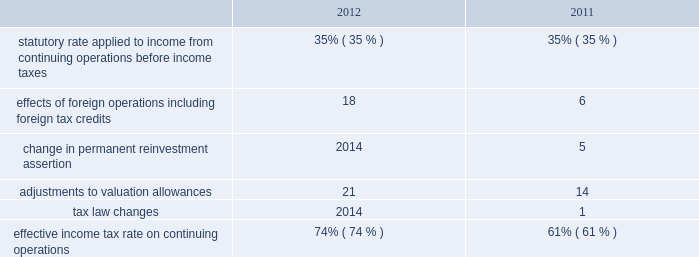Provision for income taxes increased $ 1791 million in 2012 from 2011 primarily due to the increase in pretax income from continuing operations , including the impact of the resumption of sales in libya in the first quarter of 2012 .
The following is an analysis of the effective income tax rates for 2012 and 2011: .
The effective income tax rate is influenced by a variety of factors including the geographic sources of income and the relative magnitude of these sources of income .
The provision for income taxes is allocated on a discrete , stand-alone basis to pretax segment income and to individual items not allocated to segments .
The difference between the total provision and the sum of the amounts allocated to segments appears in the "corporate and other unallocated items" shown in the reconciliation of segment income to net income below .
Effects of foreign operations 2013 the effects of foreign operations on our effective tax rate increased in 2012 as compared to 2011 , primarily due to the resumption of sales in libya in the first quarter of 2012 , where the statutory rate is in excess of 90 percent .
Change in permanent reinvestment assertion 2013 in the second quarter of 2011 , we recorded $ 716 million of deferred u.s .
Tax on undistributed earnings of $ 2046 million that we previously intended to permanently reinvest in foreign operations .
Offsetting this tax expense were associated foreign tax credits of $ 488 million .
In addition , we reduced our valuation allowance related to foreign tax credits by $ 228 million due to recognizing deferred u.s .
Tax on previously undistributed earnings .
Adjustments to valuation allowances 2013 in 2012 and 2011 , we increased the valuation allowance against foreign tax credits because it is more likely than not that we will be unable to realize all u.s .
Benefits on foreign taxes accrued in those years .
See item 8 .
Financial statements and supplementary data - note 10 to the consolidated financial statements for further information about income taxes .
Discontinued operations is presented net of tax , and reflects our downstream business that was spun off june 30 , 2011 and our angola business which we agreed to sell in 2013 .
See item 8 .
Financial statements and supplementary data 2013 notes 3 and 6 to the consolidated financial statements for additional information. .
What were total adjustments to valuation allowances in millions? 
Computations: (21 + 14)
Answer: 35.0. 